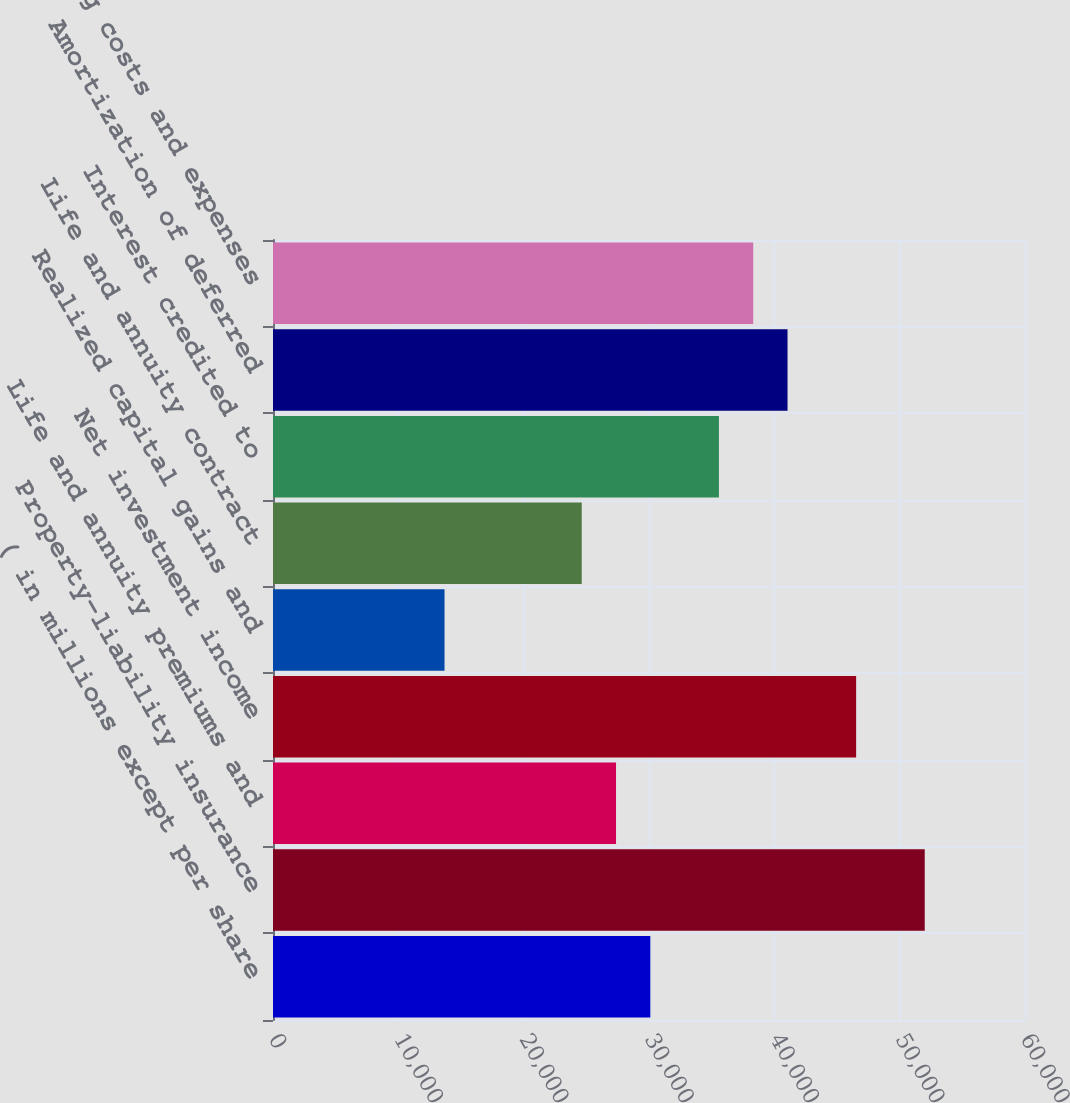Convert chart. <chart><loc_0><loc_0><loc_500><loc_500><bar_chart><fcel>( in millions except per share<fcel>Property-liability insurance<fcel>Life and annuity premiums and<fcel>Net investment income<fcel>Realized capital gains and<fcel>Life and annuity contract<fcel>Interest credited to<fcel>Amortization of deferred<fcel>Operating costs and expenses<nl><fcel>30105.8<fcel>51999.8<fcel>27369<fcel>46526.3<fcel>13685.2<fcel>24632.2<fcel>35579.3<fcel>41052.8<fcel>38316<nl></chart> 